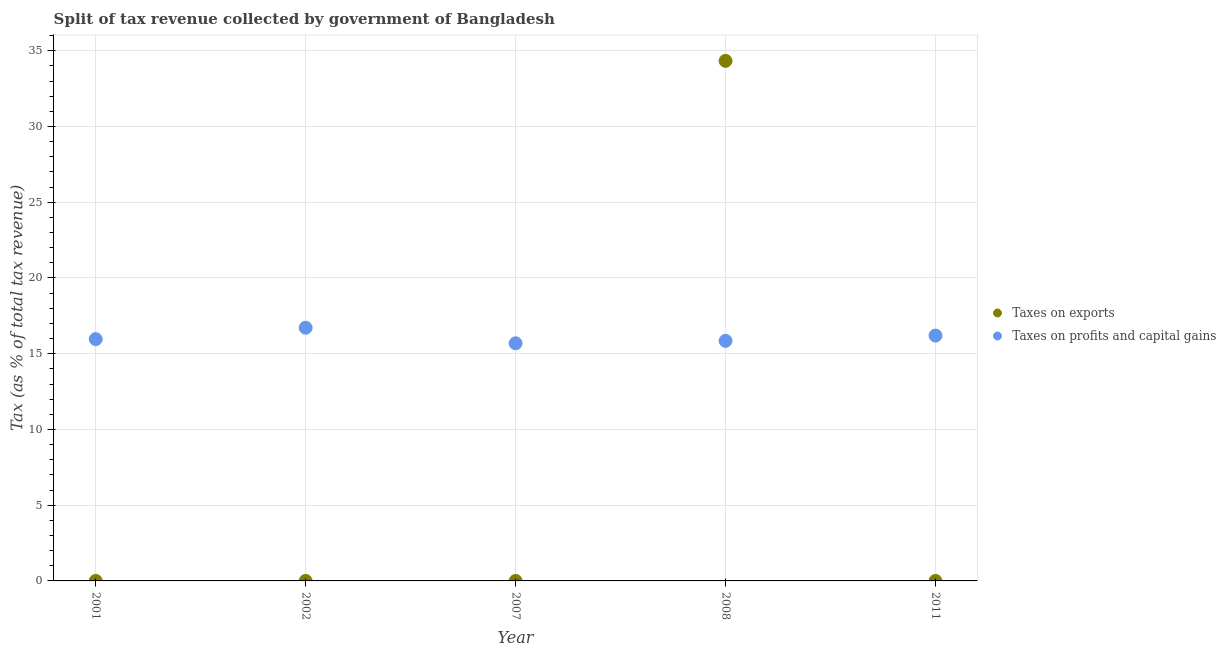How many different coloured dotlines are there?
Keep it short and to the point. 2. Is the number of dotlines equal to the number of legend labels?
Offer a terse response. Yes. What is the percentage of revenue obtained from taxes on profits and capital gains in 2001?
Your response must be concise. 15.96. Across all years, what is the maximum percentage of revenue obtained from taxes on profits and capital gains?
Your answer should be compact. 16.72. Across all years, what is the minimum percentage of revenue obtained from taxes on exports?
Keep it short and to the point. 1.00567926439932e-6. In which year was the percentage of revenue obtained from taxes on exports maximum?
Give a very brief answer. 2008. In which year was the percentage of revenue obtained from taxes on exports minimum?
Make the answer very short. 2011. What is the total percentage of revenue obtained from taxes on profits and capital gains in the graph?
Provide a short and direct response. 80.42. What is the difference between the percentage of revenue obtained from taxes on exports in 2002 and that in 2011?
Offer a terse response. 3.7494982799024108e-6. What is the difference between the percentage of revenue obtained from taxes on profits and capital gains in 2011 and the percentage of revenue obtained from taxes on exports in 2007?
Provide a short and direct response. 16.2. What is the average percentage of revenue obtained from taxes on profits and capital gains per year?
Your answer should be very brief. 16.08. In the year 2008, what is the difference between the percentage of revenue obtained from taxes on profits and capital gains and percentage of revenue obtained from taxes on exports?
Provide a short and direct response. -18.48. What is the ratio of the percentage of revenue obtained from taxes on exports in 2002 to that in 2007?
Make the answer very short. 0.05. Is the difference between the percentage of revenue obtained from taxes on profits and capital gains in 2007 and 2011 greater than the difference between the percentage of revenue obtained from taxes on exports in 2007 and 2011?
Provide a short and direct response. No. What is the difference between the highest and the second highest percentage of revenue obtained from taxes on exports?
Keep it short and to the point. 34.33. What is the difference between the highest and the lowest percentage of revenue obtained from taxes on exports?
Make the answer very short. 34.33. In how many years, is the percentage of revenue obtained from taxes on exports greater than the average percentage of revenue obtained from taxes on exports taken over all years?
Offer a very short reply. 1. Is the sum of the percentage of revenue obtained from taxes on exports in 2001 and 2008 greater than the maximum percentage of revenue obtained from taxes on profits and capital gains across all years?
Provide a succinct answer. Yes. Does the percentage of revenue obtained from taxes on profits and capital gains monotonically increase over the years?
Your answer should be compact. No. Is the percentage of revenue obtained from taxes on profits and capital gains strictly greater than the percentage of revenue obtained from taxes on exports over the years?
Your answer should be compact. No. Are the values on the major ticks of Y-axis written in scientific E-notation?
Make the answer very short. No. Does the graph contain grids?
Your answer should be very brief. Yes. How many legend labels are there?
Make the answer very short. 2. What is the title of the graph?
Provide a succinct answer. Split of tax revenue collected by government of Bangladesh. Does "Urban" appear as one of the legend labels in the graph?
Give a very brief answer. No. What is the label or title of the X-axis?
Keep it short and to the point. Year. What is the label or title of the Y-axis?
Provide a succinct answer. Tax (as % of total tax revenue). What is the Tax (as % of total tax revenue) in Taxes on exports in 2001?
Provide a succinct answer. 0. What is the Tax (as % of total tax revenue) of Taxes on profits and capital gains in 2001?
Give a very brief answer. 15.96. What is the Tax (as % of total tax revenue) in Taxes on exports in 2002?
Provide a short and direct response. 4.755177544301731e-6. What is the Tax (as % of total tax revenue) of Taxes on profits and capital gains in 2002?
Ensure brevity in your answer.  16.72. What is the Tax (as % of total tax revenue) in Taxes on exports in 2007?
Give a very brief answer. 8.887465632262429e-5. What is the Tax (as % of total tax revenue) of Taxes on profits and capital gains in 2007?
Provide a short and direct response. 15.69. What is the Tax (as % of total tax revenue) of Taxes on exports in 2008?
Make the answer very short. 34.33. What is the Tax (as % of total tax revenue) in Taxes on profits and capital gains in 2008?
Your response must be concise. 15.85. What is the Tax (as % of total tax revenue) in Taxes on exports in 2011?
Your answer should be very brief. 1.00567926439932e-6. What is the Tax (as % of total tax revenue) in Taxes on profits and capital gains in 2011?
Ensure brevity in your answer.  16.2. Across all years, what is the maximum Tax (as % of total tax revenue) of Taxes on exports?
Make the answer very short. 34.33. Across all years, what is the maximum Tax (as % of total tax revenue) of Taxes on profits and capital gains?
Your response must be concise. 16.72. Across all years, what is the minimum Tax (as % of total tax revenue) in Taxes on exports?
Your answer should be compact. 1.00567926439932e-6. Across all years, what is the minimum Tax (as % of total tax revenue) of Taxes on profits and capital gains?
Your answer should be compact. 15.69. What is the total Tax (as % of total tax revenue) of Taxes on exports in the graph?
Your answer should be compact. 34.34. What is the total Tax (as % of total tax revenue) in Taxes on profits and capital gains in the graph?
Provide a short and direct response. 80.42. What is the difference between the Tax (as % of total tax revenue) in Taxes on exports in 2001 and that in 2002?
Provide a succinct answer. 0. What is the difference between the Tax (as % of total tax revenue) of Taxes on profits and capital gains in 2001 and that in 2002?
Offer a terse response. -0.75. What is the difference between the Tax (as % of total tax revenue) of Taxes on exports in 2001 and that in 2007?
Provide a short and direct response. 0. What is the difference between the Tax (as % of total tax revenue) of Taxes on profits and capital gains in 2001 and that in 2007?
Give a very brief answer. 0.28. What is the difference between the Tax (as % of total tax revenue) in Taxes on exports in 2001 and that in 2008?
Your answer should be compact. -34.33. What is the difference between the Tax (as % of total tax revenue) of Taxes on profits and capital gains in 2001 and that in 2008?
Give a very brief answer. 0.11. What is the difference between the Tax (as % of total tax revenue) of Taxes on exports in 2001 and that in 2011?
Ensure brevity in your answer.  0. What is the difference between the Tax (as % of total tax revenue) of Taxes on profits and capital gains in 2001 and that in 2011?
Your answer should be compact. -0.23. What is the difference between the Tax (as % of total tax revenue) of Taxes on exports in 2002 and that in 2007?
Provide a succinct answer. -0. What is the difference between the Tax (as % of total tax revenue) of Taxes on profits and capital gains in 2002 and that in 2007?
Ensure brevity in your answer.  1.03. What is the difference between the Tax (as % of total tax revenue) in Taxes on exports in 2002 and that in 2008?
Provide a short and direct response. -34.33. What is the difference between the Tax (as % of total tax revenue) in Taxes on profits and capital gains in 2002 and that in 2008?
Your answer should be compact. 0.87. What is the difference between the Tax (as % of total tax revenue) in Taxes on exports in 2002 and that in 2011?
Provide a short and direct response. 0. What is the difference between the Tax (as % of total tax revenue) of Taxes on profits and capital gains in 2002 and that in 2011?
Provide a short and direct response. 0.52. What is the difference between the Tax (as % of total tax revenue) in Taxes on exports in 2007 and that in 2008?
Ensure brevity in your answer.  -34.33. What is the difference between the Tax (as % of total tax revenue) in Taxes on profits and capital gains in 2007 and that in 2008?
Provide a short and direct response. -0.16. What is the difference between the Tax (as % of total tax revenue) of Taxes on exports in 2007 and that in 2011?
Provide a succinct answer. 0. What is the difference between the Tax (as % of total tax revenue) in Taxes on profits and capital gains in 2007 and that in 2011?
Your response must be concise. -0.51. What is the difference between the Tax (as % of total tax revenue) in Taxes on exports in 2008 and that in 2011?
Give a very brief answer. 34.33. What is the difference between the Tax (as % of total tax revenue) in Taxes on profits and capital gains in 2008 and that in 2011?
Offer a terse response. -0.35. What is the difference between the Tax (as % of total tax revenue) of Taxes on exports in 2001 and the Tax (as % of total tax revenue) of Taxes on profits and capital gains in 2002?
Your response must be concise. -16.71. What is the difference between the Tax (as % of total tax revenue) of Taxes on exports in 2001 and the Tax (as % of total tax revenue) of Taxes on profits and capital gains in 2007?
Give a very brief answer. -15.69. What is the difference between the Tax (as % of total tax revenue) of Taxes on exports in 2001 and the Tax (as % of total tax revenue) of Taxes on profits and capital gains in 2008?
Offer a terse response. -15.85. What is the difference between the Tax (as % of total tax revenue) of Taxes on exports in 2001 and the Tax (as % of total tax revenue) of Taxes on profits and capital gains in 2011?
Offer a terse response. -16.2. What is the difference between the Tax (as % of total tax revenue) of Taxes on exports in 2002 and the Tax (as % of total tax revenue) of Taxes on profits and capital gains in 2007?
Your answer should be compact. -15.69. What is the difference between the Tax (as % of total tax revenue) in Taxes on exports in 2002 and the Tax (as % of total tax revenue) in Taxes on profits and capital gains in 2008?
Your answer should be compact. -15.85. What is the difference between the Tax (as % of total tax revenue) in Taxes on exports in 2002 and the Tax (as % of total tax revenue) in Taxes on profits and capital gains in 2011?
Make the answer very short. -16.2. What is the difference between the Tax (as % of total tax revenue) of Taxes on exports in 2007 and the Tax (as % of total tax revenue) of Taxes on profits and capital gains in 2008?
Provide a short and direct response. -15.85. What is the difference between the Tax (as % of total tax revenue) in Taxes on exports in 2007 and the Tax (as % of total tax revenue) in Taxes on profits and capital gains in 2011?
Keep it short and to the point. -16.2. What is the difference between the Tax (as % of total tax revenue) of Taxes on exports in 2008 and the Tax (as % of total tax revenue) of Taxes on profits and capital gains in 2011?
Your answer should be very brief. 18.14. What is the average Tax (as % of total tax revenue) of Taxes on exports per year?
Provide a succinct answer. 6.87. What is the average Tax (as % of total tax revenue) in Taxes on profits and capital gains per year?
Your response must be concise. 16.08. In the year 2001, what is the difference between the Tax (as % of total tax revenue) in Taxes on exports and Tax (as % of total tax revenue) in Taxes on profits and capital gains?
Provide a short and direct response. -15.96. In the year 2002, what is the difference between the Tax (as % of total tax revenue) in Taxes on exports and Tax (as % of total tax revenue) in Taxes on profits and capital gains?
Your answer should be compact. -16.72. In the year 2007, what is the difference between the Tax (as % of total tax revenue) of Taxes on exports and Tax (as % of total tax revenue) of Taxes on profits and capital gains?
Make the answer very short. -15.69. In the year 2008, what is the difference between the Tax (as % of total tax revenue) in Taxes on exports and Tax (as % of total tax revenue) in Taxes on profits and capital gains?
Your response must be concise. 18.48. In the year 2011, what is the difference between the Tax (as % of total tax revenue) in Taxes on exports and Tax (as % of total tax revenue) in Taxes on profits and capital gains?
Your answer should be very brief. -16.2. What is the ratio of the Tax (as % of total tax revenue) of Taxes on exports in 2001 to that in 2002?
Provide a succinct answer. 274.05. What is the ratio of the Tax (as % of total tax revenue) of Taxes on profits and capital gains in 2001 to that in 2002?
Your answer should be compact. 0.96. What is the ratio of the Tax (as % of total tax revenue) of Taxes on exports in 2001 to that in 2007?
Keep it short and to the point. 14.66. What is the ratio of the Tax (as % of total tax revenue) in Taxes on profits and capital gains in 2001 to that in 2007?
Keep it short and to the point. 1.02. What is the ratio of the Tax (as % of total tax revenue) of Taxes on exports in 2001 to that in 2011?
Your response must be concise. 1295.81. What is the ratio of the Tax (as % of total tax revenue) in Taxes on profits and capital gains in 2001 to that in 2011?
Ensure brevity in your answer.  0.99. What is the ratio of the Tax (as % of total tax revenue) of Taxes on exports in 2002 to that in 2007?
Your response must be concise. 0.05. What is the ratio of the Tax (as % of total tax revenue) of Taxes on profits and capital gains in 2002 to that in 2007?
Offer a very short reply. 1.07. What is the ratio of the Tax (as % of total tax revenue) of Taxes on exports in 2002 to that in 2008?
Offer a very short reply. 0. What is the ratio of the Tax (as % of total tax revenue) of Taxes on profits and capital gains in 2002 to that in 2008?
Make the answer very short. 1.05. What is the ratio of the Tax (as % of total tax revenue) of Taxes on exports in 2002 to that in 2011?
Your answer should be very brief. 4.73. What is the ratio of the Tax (as % of total tax revenue) of Taxes on profits and capital gains in 2002 to that in 2011?
Keep it short and to the point. 1.03. What is the ratio of the Tax (as % of total tax revenue) of Taxes on exports in 2007 to that in 2011?
Give a very brief answer. 88.37. What is the ratio of the Tax (as % of total tax revenue) of Taxes on profits and capital gains in 2007 to that in 2011?
Keep it short and to the point. 0.97. What is the ratio of the Tax (as % of total tax revenue) of Taxes on exports in 2008 to that in 2011?
Offer a very short reply. 3.41e+07. What is the ratio of the Tax (as % of total tax revenue) of Taxes on profits and capital gains in 2008 to that in 2011?
Provide a succinct answer. 0.98. What is the difference between the highest and the second highest Tax (as % of total tax revenue) in Taxes on exports?
Provide a succinct answer. 34.33. What is the difference between the highest and the second highest Tax (as % of total tax revenue) of Taxes on profits and capital gains?
Ensure brevity in your answer.  0.52. What is the difference between the highest and the lowest Tax (as % of total tax revenue) of Taxes on exports?
Give a very brief answer. 34.33. What is the difference between the highest and the lowest Tax (as % of total tax revenue) in Taxes on profits and capital gains?
Provide a short and direct response. 1.03. 